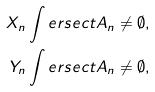Convert formula to latex. <formula><loc_0><loc_0><loc_500><loc_500>X _ { n } \int e r s e c t A _ { n } & \neq \emptyset , \\ Y _ { n } \int e r s e c t A _ { n } & \neq \emptyset ,</formula> 